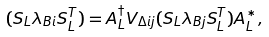Convert formula to latex. <formula><loc_0><loc_0><loc_500><loc_500>( S _ { L } \lambda _ { B i } S _ { L } ^ { T } ) = A _ { L } ^ { \dagger } V _ { \Delta i j } ( S _ { L } \lambda _ { B j } S _ { L } ^ { T } ) A _ { L } ^ { * } ,</formula> 